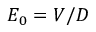<formula> <loc_0><loc_0><loc_500><loc_500>E _ { 0 } = V / D</formula> 